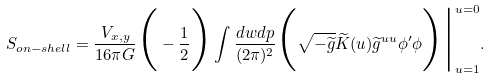<formula> <loc_0><loc_0><loc_500><loc_500>S _ { o n - s h e l l } = \frac { V _ { x , y } } { 1 6 \pi G } \Big ( - \frac { 1 } { 2 } \Big ) \int \frac { d w d p } { ( 2 \pi ) ^ { 2 } } \Big ( \sqrt { - \widetilde { g } } \widetilde { K } ( u ) \widetilde { g } ^ { u u } \phi ^ { \prime } \phi \Big ) \Big | _ { u = 1 } ^ { u = 0 } .</formula> 